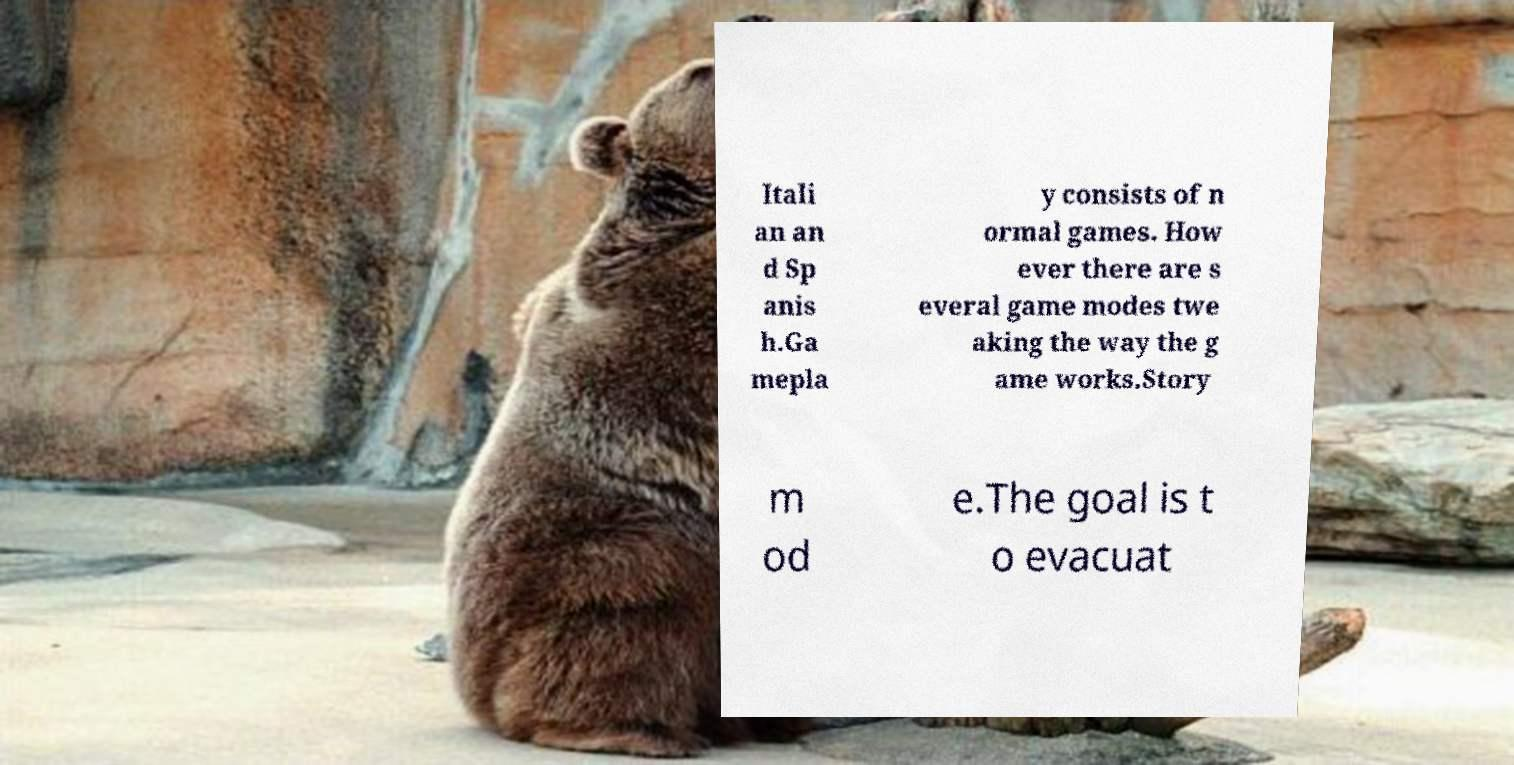Please read and relay the text visible in this image. What does it say? Itali an an d Sp anis h.Ga mepla y consists of n ormal games. How ever there are s everal game modes twe aking the way the g ame works.Story m od e.The goal is t o evacuat 